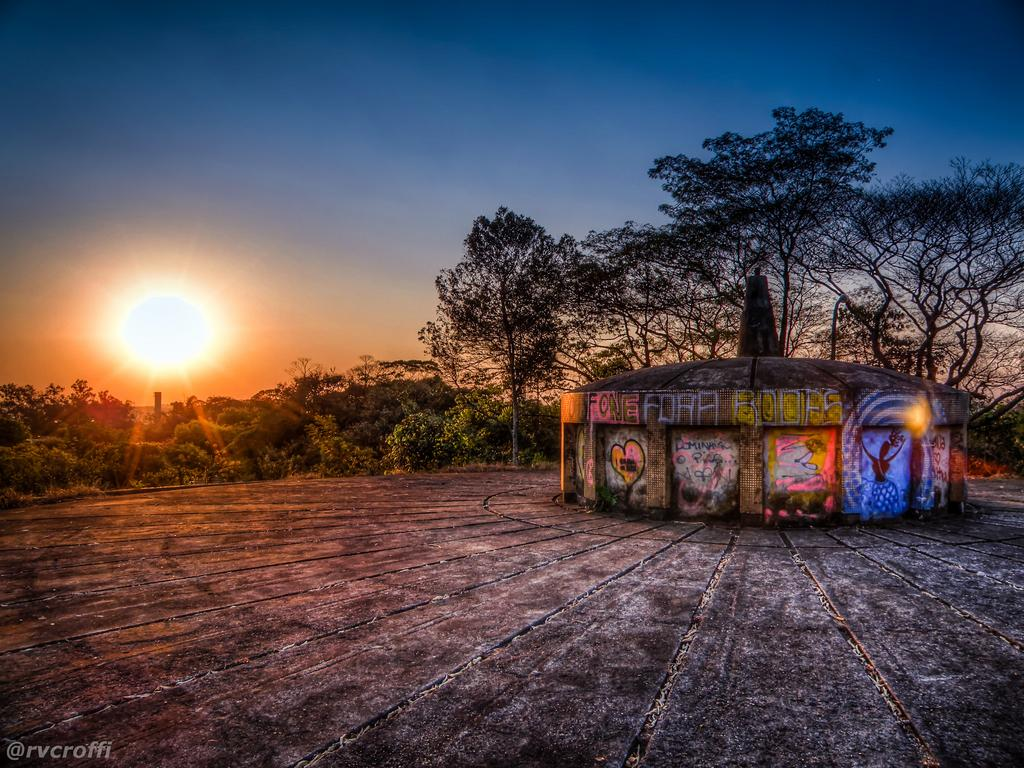What is depicted on the walls of the architecture in the image? There is graffiti on the walls of an architecture in the image. What type of vegetation can be seen in the image? There are plants and trees in the image. What is visible in the sky in the image? The sun is visible in the sky in the image. Can you describe any additional features of the image? There is a watermark on the image. What type of riddle is being solved by the balloon in the image? There is no balloon or riddle present in the image. Can you describe the plane that is flying in the image? There is no plane present in the image. 